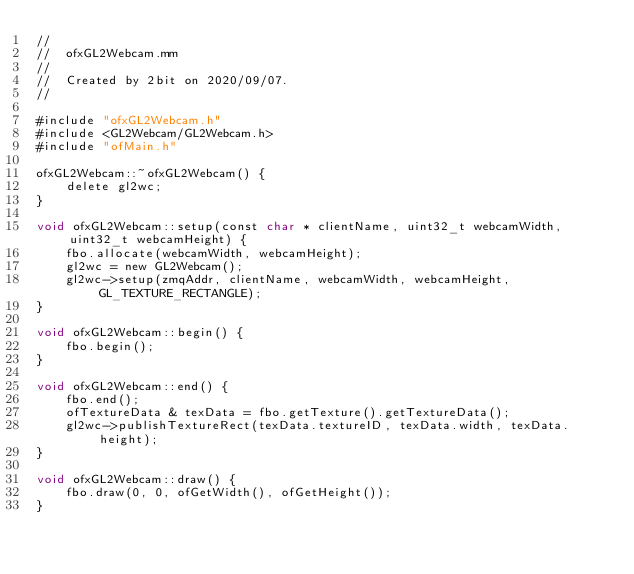<code> <loc_0><loc_0><loc_500><loc_500><_ObjectiveC_>//
//  ofxGL2Webcam.mm
//
//  Created by 2bit on 2020/09/07.
//

#include "ofxGL2Webcam.h"
#include <GL2Webcam/GL2Webcam.h>
#include "ofMain.h"

ofxGL2Webcam::~ofxGL2Webcam() {
    delete gl2wc;
}

void ofxGL2Webcam::setup(const char * clientName, uint32_t webcamWidth, uint32_t webcamHeight) {
    fbo.allocate(webcamWidth, webcamHeight);
    gl2wc = new GL2Webcam();
    gl2wc->setup(zmqAddr, clientName, webcamWidth, webcamHeight, GL_TEXTURE_RECTANGLE);
}

void ofxGL2Webcam::begin() {
    fbo.begin();
}

void ofxGL2Webcam::end() {
    fbo.end();
    ofTextureData & texData = fbo.getTexture().getTextureData();
    gl2wc->publishTextureRect(texData.textureID, texData.width, texData.height);
}

void ofxGL2Webcam::draw() {
    fbo.draw(0, 0, ofGetWidth(), ofGetHeight());
}
</code> 